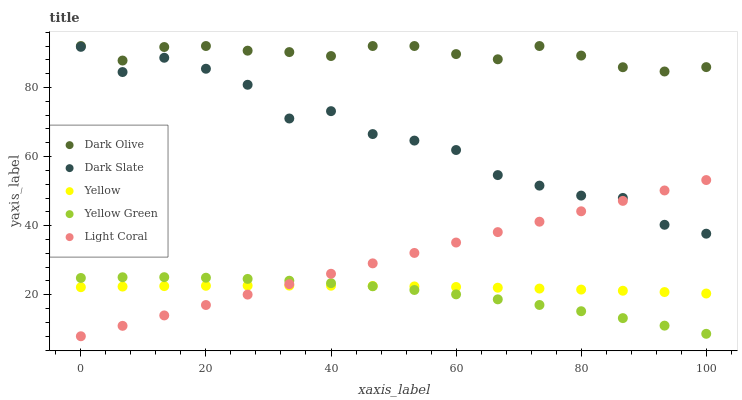Does Yellow Green have the minimum area under the curve?
Answer yes or no. Yes. Does Dark Olive have the maximum area under the curve?
Answer yes or no. Yes. Does Dark Slate have the minimum area under the curve?
Answer yes or no. No. Does Dark Slate have the maximum area under the curve?
Answer yes or no. No. Is Light Coral the smoothest?
Answer yes or no. Yes. Is Dark Slate the roughest?
Answer yes or no. Yes. Is Dark Olive the smoothest?
Answer yes or no. No. Is Dark Olive the roughest?
Answer yes or no. No. Does Light Coral have the lowest value?
Answer yes or no. Yes. Does Dark Slate have the lowest value?
Answer yes or no. No. Does Dark Olive have the highest value?
Answer yes or no. Yes. Does Dark Slate have the highest value?
Answer yes or no. No. Is Yellow Green less than Dark Olive?
Answer yes or no. Yes. Is Dark Olive greater than Yellow Green?
Answer yes or no. Yes. Does Yellow intersect Light Coral?
Answer yes or no. Yes. Is Yellow less than Light Coral?
Answer yes or no. No. Is Yellow greater than Light Coral?
Answer yes or no. No. Does Yellow Green intersect Dark Olive?
Answer yes or no. No. 